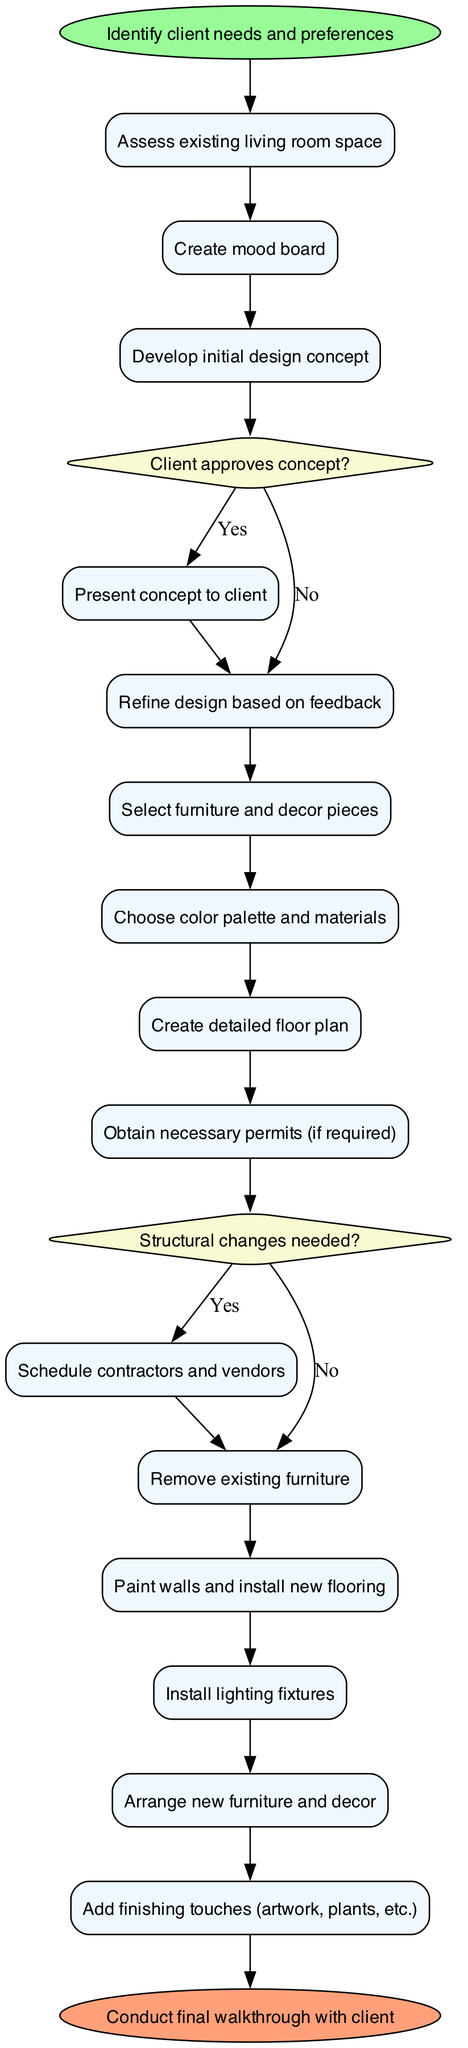What is the starting point of the redesign process? The starting point of the redesign process is "Identify client needs and preferences." This is explicitly mentioned as the start node in the diagram.
Answer: Identify client needs and preferences How many activities are involved in the process? By counting the activities listed in the diagram, there are 14 specific activities that are part of the redesign process.
Answer: 14 What happens if the client does not approve the initial design concept? If the client does not approve the initial design concept, the next step is to "Refine design based on feedback," as indicated in the decision node that follows the initial design concept.
Answer: Refine design based on feedback Which activity precedes the scheduling of contractors and vendors? "Obtain necessary permits (if required)" precedes the scheduling of contractors and vendors, as shown in the decision structure where "Structural changes needed?" leads to obtaining permits.
Answer: Obtain necessary permits How many decision nodes are present in the diagram? The diagram contains 2 decision nodes that involve critical choices related to the approval of the design concept and the need for permits based on structural changes.
Answer: 2 What is the final step in the redesign process? The final step in the redesign process is "Conduct final walkthrough with client," which is stated as the end node in the diagram.
Answer: Conduct final walkthrough with client If structural changes are needed, what is the next step after obtaining permits? After obtaining necessary permits (if required), the next step is to "Schedule contractors and vendors," which follows the decision tree from the structural changes question.
Answer: Schedule contractors and vendors What color is used for the start node? The color used for the start node is green, specifically represented as '#98FB98' in the diagram's color definitions.
Answer: Green 